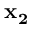Convert formula to latex. <formula><loc_0><loc_0><loc_500><loc_500>x _ { 2 }</formula> 